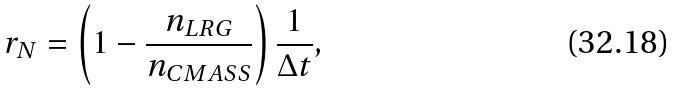<formula> <loc_0><loc_0><loc_500><loc_500>r _ { N } = \left ( 1 - \frac { n _ { L R G } } { n _ { C M A S S } } \right ) \frac { 1 } { \Delta t } ,</formula> 